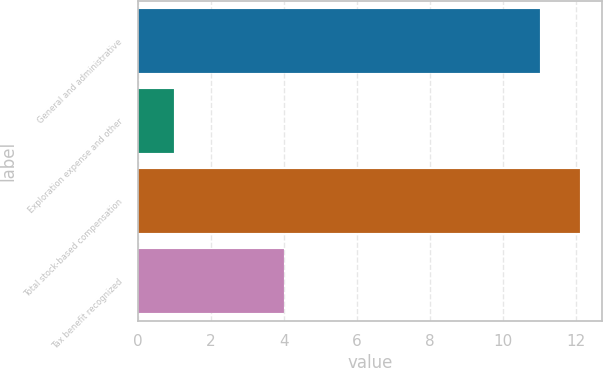Convert chart to OTSL. <chart><loc_0><loc_0><loc_500><loc_500><bar_chart><fcel>General and administrative<fcel>Exploration expense and other<fcel>Total stock-based compensation<fcel>Tax benefit recognized<nl><fcel>11<fcel>1<fcel>12.1<fcel>4<nl></chart> 